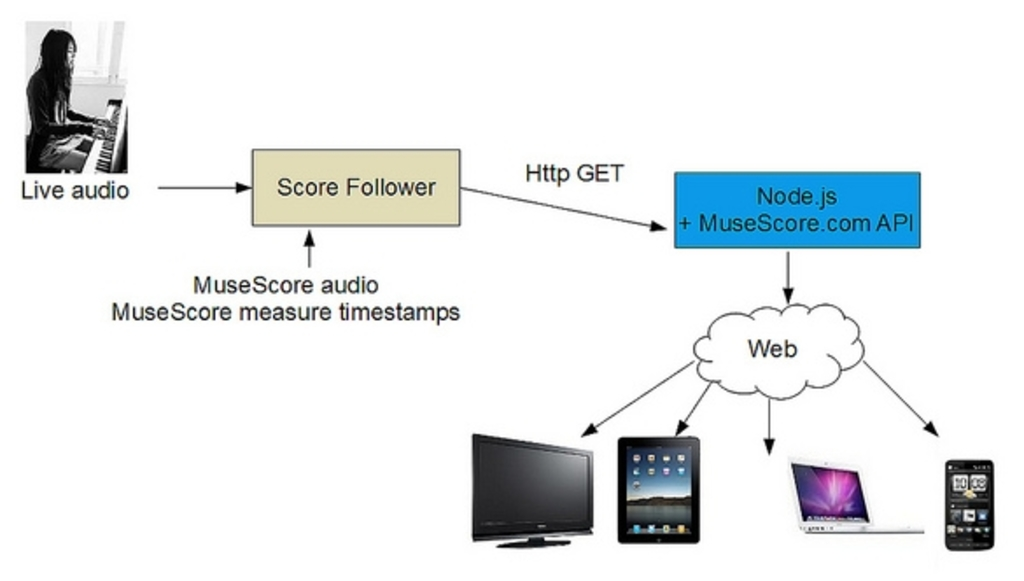What are the key elements in this picture?
 The image presents a flowchart that outlines the process of how live audio is processed and distributed to various devices using MuseScore audio and measure timestamps. The journey of the audio begins at the live audio source, from where it is directed to the score follower. The score follower then sends the audio to the HTTP GET. The next step in the process involves Node.js and the MuseScore.com API, which are responsible for transmitting the audio to the final destinations: a laptop, a tablet, and a smartphone. The flowchart provides a clear and concise representation of the path that the audio takes from its source to its final destinations, highlighting the role of MuseScore in the process. 